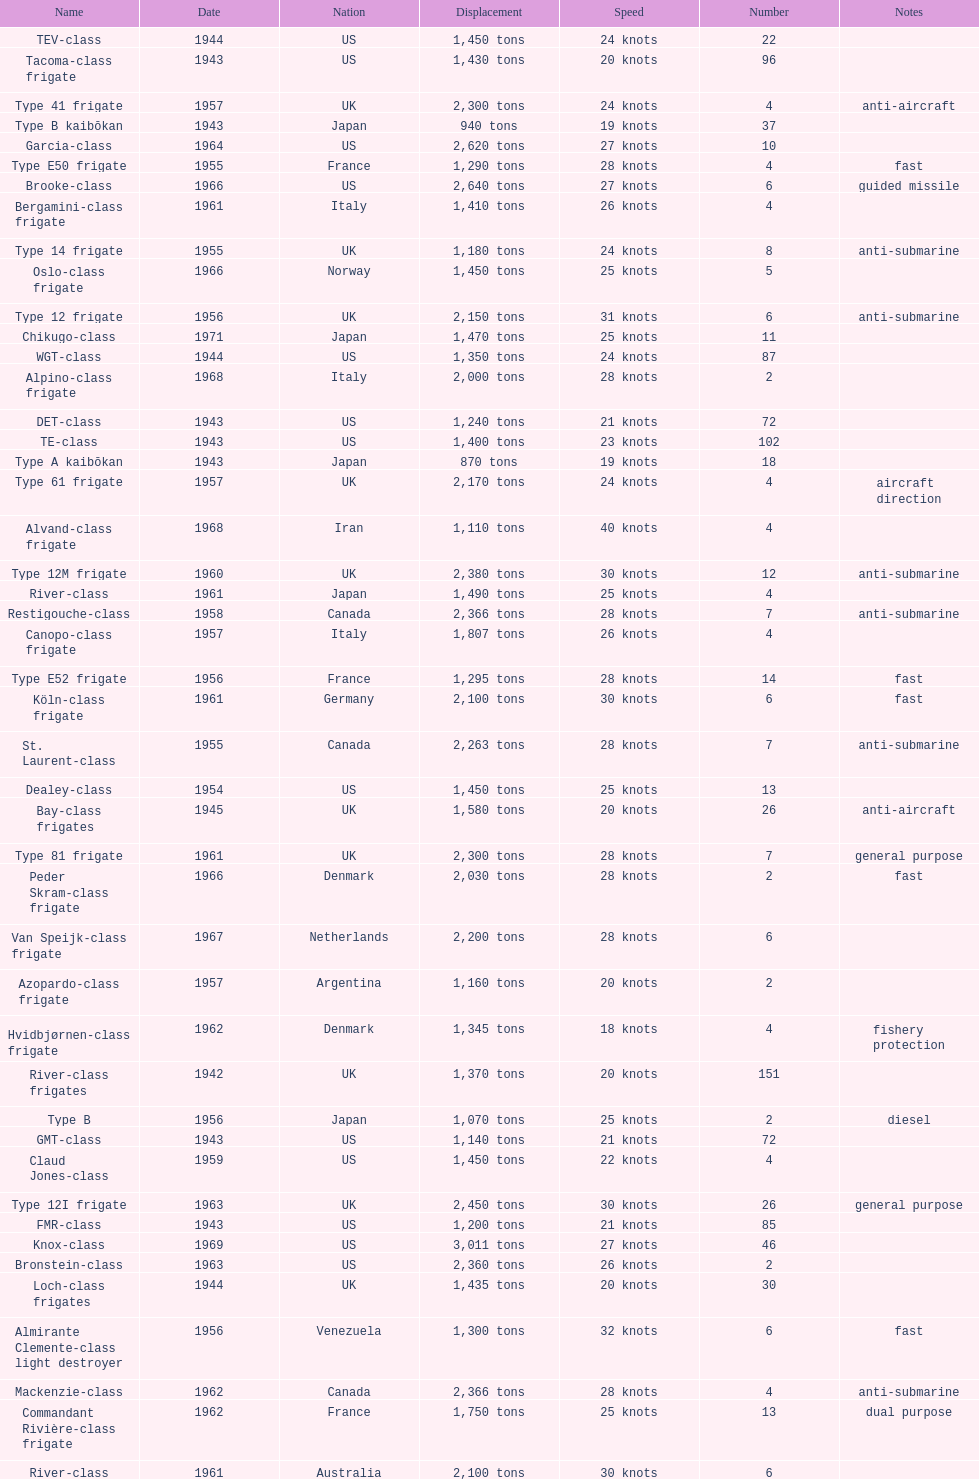Which name has the largest displacement? Knox-class. 